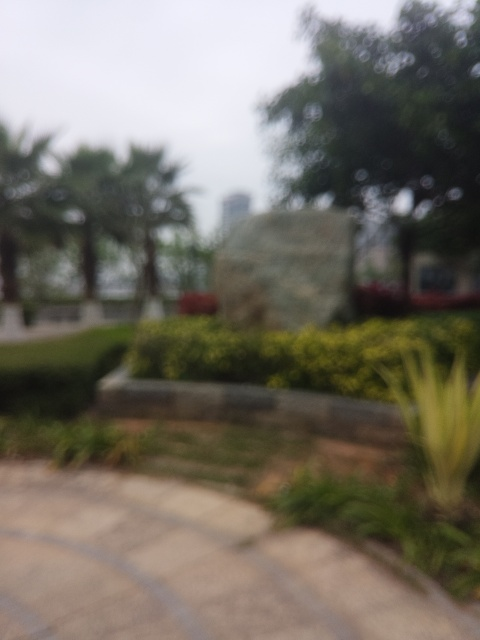What mood does this image evoke? Despite the blur, the image exudes a serene and somewhat mysterious mood. The presence of greenery and the open space suggest a peaceful environment, inviting quiet reflection. The blurred details add to the mystery, leaving the specifics to the viewer's imagination and perhaps evoking a sense of curiosity or nostalgia. 